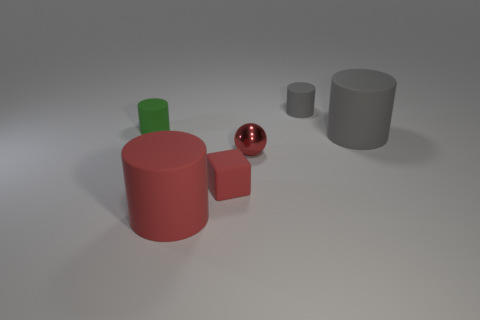What is the shape of the small thing that is the same color as the sphere?
Provide a succinct answer. Cube. Does the red metal sphere have the same size as the matte cylinder that is in front of the metal sphere?
Your answer should be compact. No. How many other things are made of the same material as the tiny red cube?
Your answer should be compact. 4. Is there anything else that is the same shape as the small red matte thing?
Your response must be concise. No. There is a large matte thing in front of the thing that is right of the object that is behind the small green rubber object; what is its color?
Ensure brevity in your answer.  Red. There is a small rubber thing that is both behind the matte cube and right of the green rubber cylinder; what is its shape?
Your response must be concise. Cylinder. Is there anything else that is the same size as the red rubber cylinder?
Provide a short and direct response. Yes. The big object right of the small gray matte object that is behind the tiny ball is what color?
Offer a very short reply. Gray. What is the shape of the small matte thing that is in front of the gray cylinder in front of the small cylinder that is left of the small gray cylinder?
Your answer should be compact. Cube. How big is the cylinder that is both on the left side of the sphere and behind the tiny cube?
Give a very brief answer. Small. 